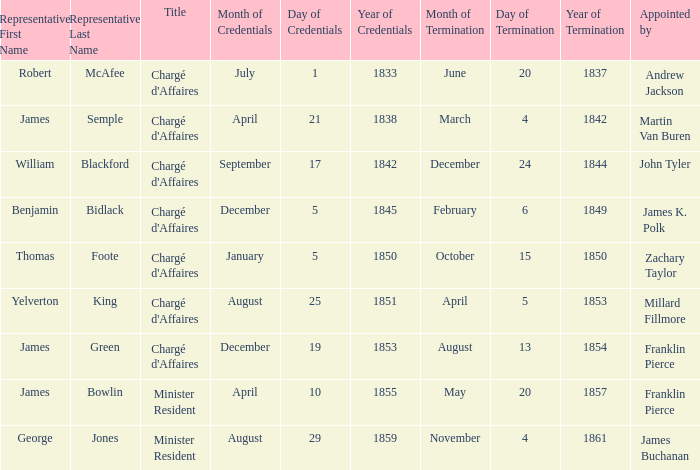Which title is associated with a mission termination date of november 4, 1861? Minister Resident. 